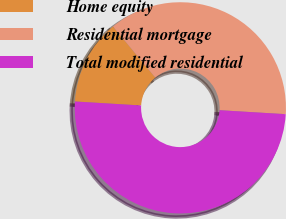Convert chart. <chart><loc_0><loc_0><loc_500><loc_500><pie_chart><fcel>Home equity<fcel>Residential mortgage<fcel>Total modified residential<nl><fcel>13.03%<fcel>36.97%<fcel>50.0%<nl></chart> 